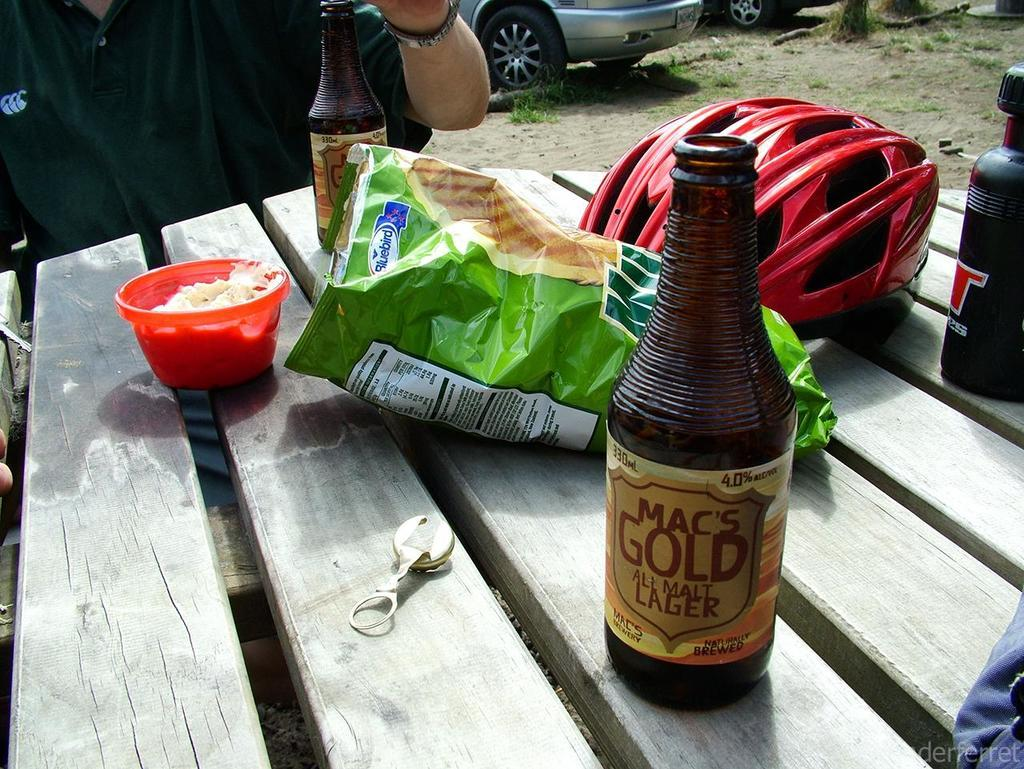What is the main piece of furniture in the image? There is a table in the image. What items can be seen on the table? There is a chips packet, a bottle, a motorcycle key, a bag, and a helmet on the table. What is the person in the image doing? There is a person sitting in a chair. What can be seen on the road in the image? There is a car on the road. What type of pie is being served to the person in the image? There is no pie present in the image. What is the person in the image doing to avoid going to prison? There is no indication of any prison-related activity in the image. 